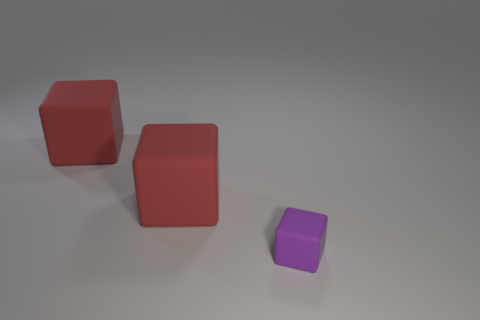Are there any other things that have the same material as the tiny purple object?
Ensure brevity in your answer.  Yes. What is the size of the purple rubber block?
Provide a short and direct response. Small. How many rubber cubes are in front of the small thing?
Offer a very short reply. 0. How many other things are the same color as the tiny rubber thing?
Provide a short and direct response. 0. How many objects are matte blocks behind the small rubber thing or blocks left of the purple rubber thing?
Provide a short and direct response. 2. Are there more small rubber objects than brown metal balls?
Make the answer very short. Yes. How many objects are either matte blocks on the left side of the tiny purple thing or large red matte cubes?
Your response must be concise. 2. What is the tiny purple thing made of?
Your answer should be compact. Rubber. What number of cubes are either large red matte objects or small purple things?
Offer a very short reply. 3. Are there any other things that are made of the same material as the purple block?
Your answer should be compact. Yes. 